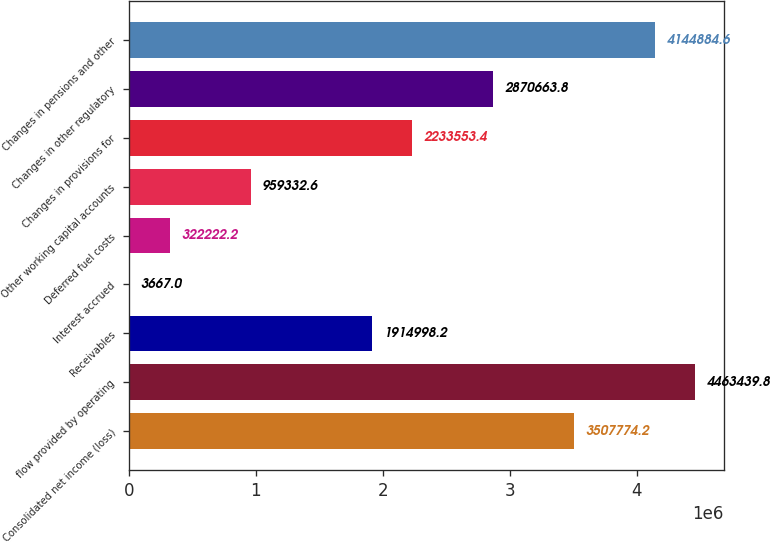Convert chart to OTSL. <chart><loc_0><loc_0><loc_500><loc_500><bar_chart><fcel>Consolidated net income (loss)<fcel>flow provided by operating<fcel>Receivables<fcel>Interest accrued<fcel>Deferred fuel costs<fcel>Other working capital accounts<fcel>Changes in provisions for<fcel>Changes in other regulatory<fcel>Changes in pensions and other<nl><fcel>3.50777e+06<fcel>4.46344e+06<fcel>1.915e+06<fcel>3667<fcel>322222<fcel>959333<fcel>2.23355e+06<fcel>2.87066e+06<fcel>4.14488e+06<nl></chart> 